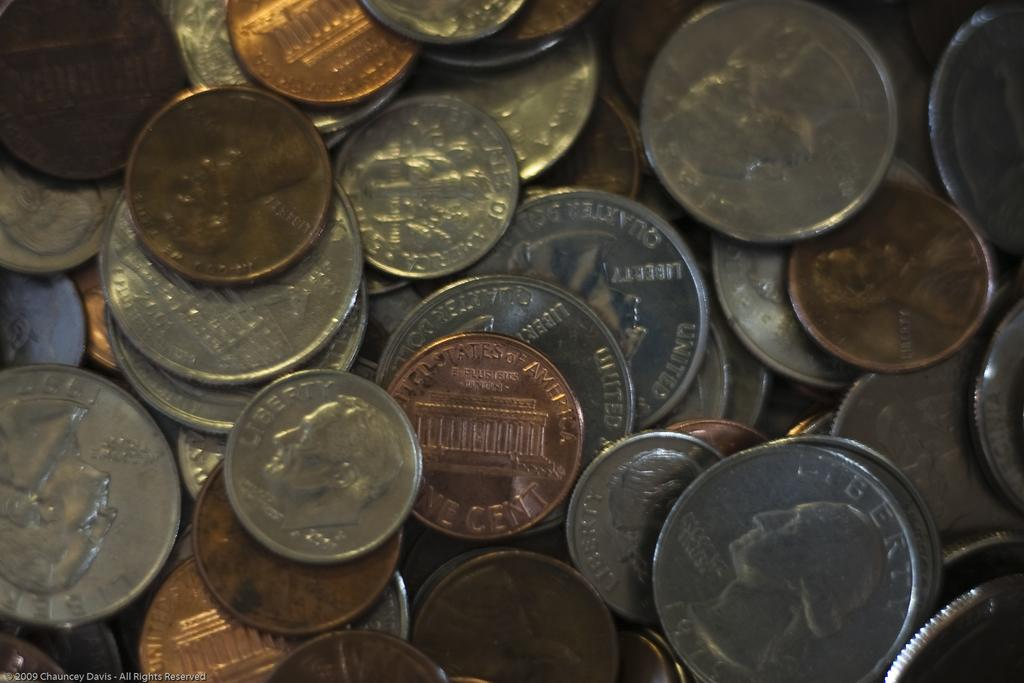<image>
Offer a succinct explanation of the picture presented. A collection of many coins, including a 1979 quarter. 